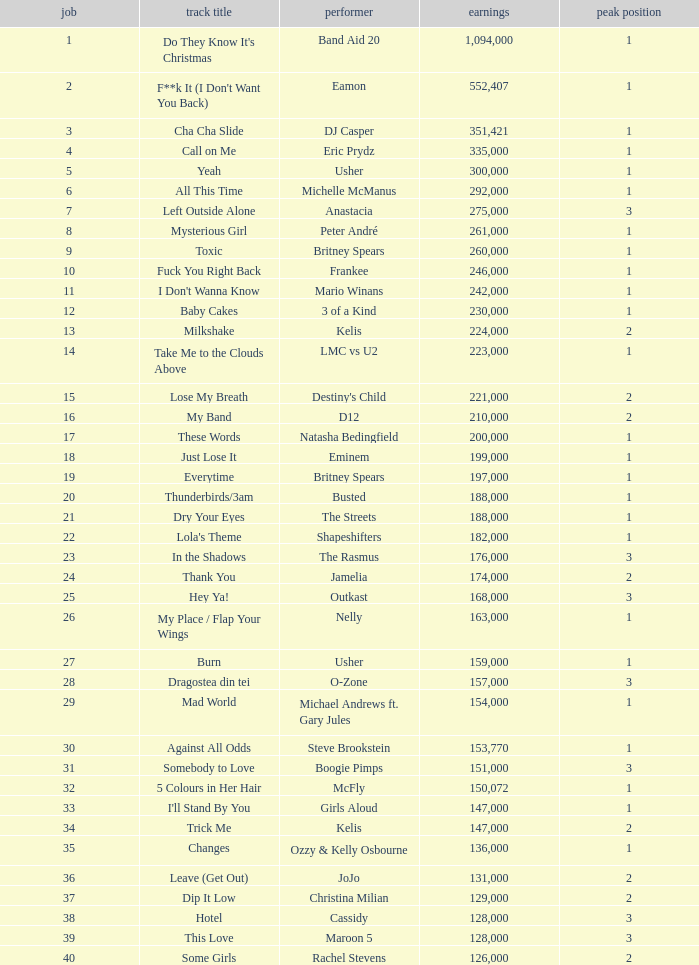What were the sales for Dj Casper when he was in a position lower than 13? 351421.0. 